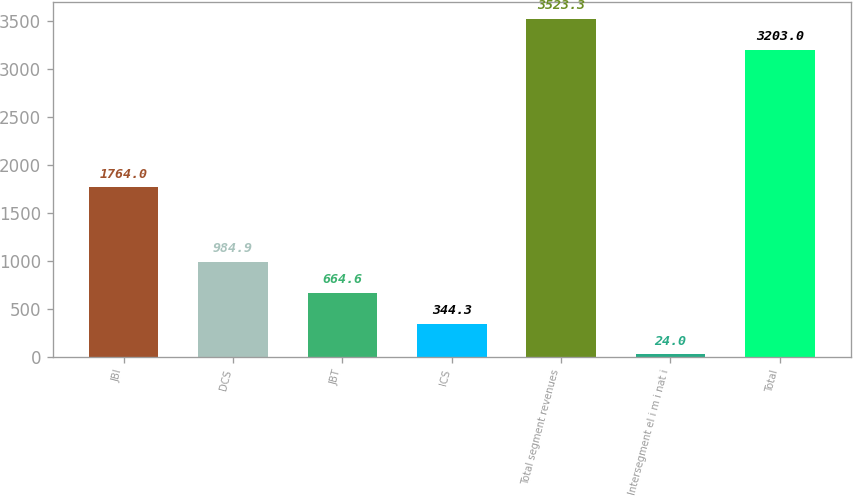Convert chart. <chart><loc_0><loc_0><loc_500><loc_500><bar_chart><fcel>JBI<fcel>DCS<fcel>JBT<fcel>ICS<fcel>Total segment revenues<fcel>Intersegment el i m i nat i<fcel>Total<nl><fcel>1764<fcel>984.9<fcel>664.6<fcel>344.3<fcel>3523.3<fcel>24<fcel>3203<nl></chart> 